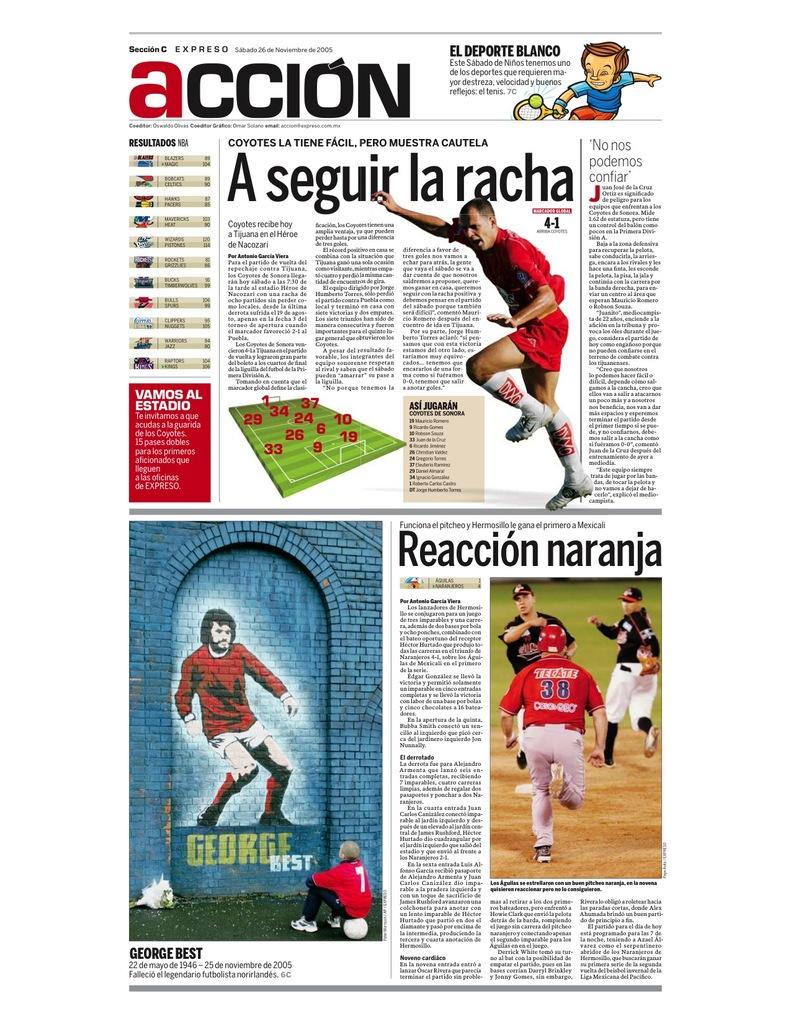What is the name of the man in the painting?
Your response must be concise. George best. Is this a sports magazine?
Ensure brevity in your answer.  Yes. 